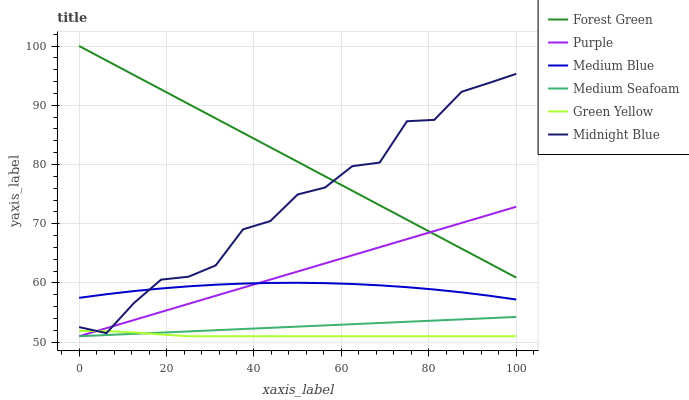Does Green Yellow have the minimum area under the curve?
Answer yes or no. Yes. Does Forest Green have the maximum area under the curve?
Answer yes or no. Yes. Does Purple have the minimum area under the curve?
Answer yes or no. No. Does Purple have the maximum area under the curve?
Answer yes or no. No. Is Medium Seafoam the smoothest?
Answer yes or no. Yes. Is Midnight Blue the roughest?
Answer yes or no. Yes. Is Purple the smoothest?
Answer yes or no. No. Is Purple the roughest?
Answer yes or no. No. Does Medium Blue have the lowest value?
Answer yes or no. No. Does Purple have the highest value?
Answer yes or no. No. Is Medium Seafoam less than Forest Green?
Answer yes or no. Yes. Is Forest Green greater than Medium Seafoam?
Answer yes or no. Yes. Does Medium Seafoam intersect Forest Green?
Answer yes or no. No. 